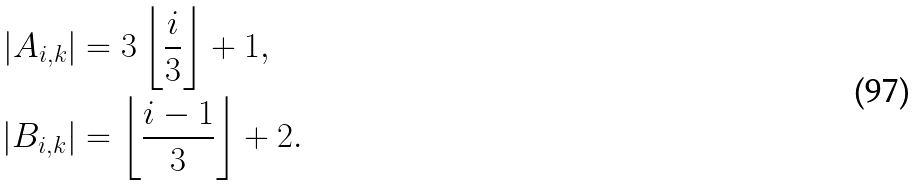Convert formula to latex. <formula><loc_0><loc_0><loc_500><loc_500>| A _ { i , k } | & = 3 \left \lfloor \frac { i } { 3 } \right \rfloor + 1 , \\ | B _ { i , k } | & = \left \lfloor \frac { i - 1 } { 3 } \right \rfloor + 2 .</formula> 